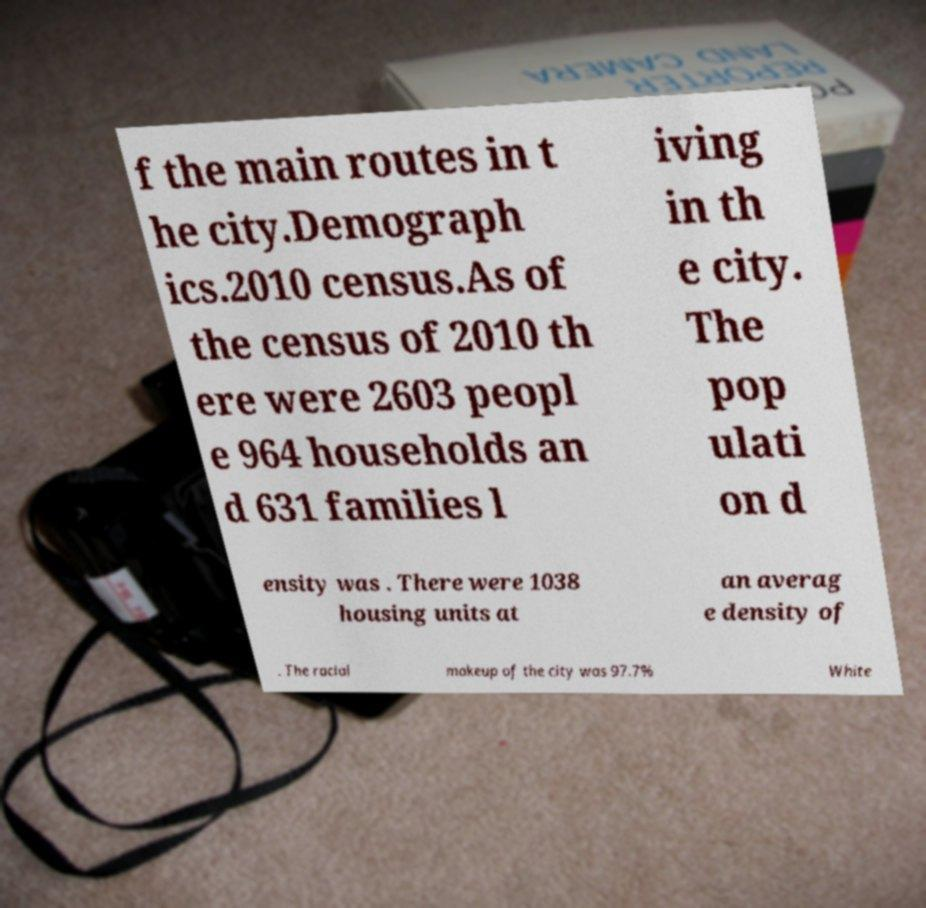What messages or text are displayed in this image? I need them in a readable, typed format. f the main routes in t he city.Demograph ics.2010 census.As of the census of 2010 th ere were 2603 peopl e 964 households an d 631 families l iving in th e city. The pop ulati on d ensity was . There were 1038 housing units at an averag e density of . The racial makeup of the city was 97.7% White 